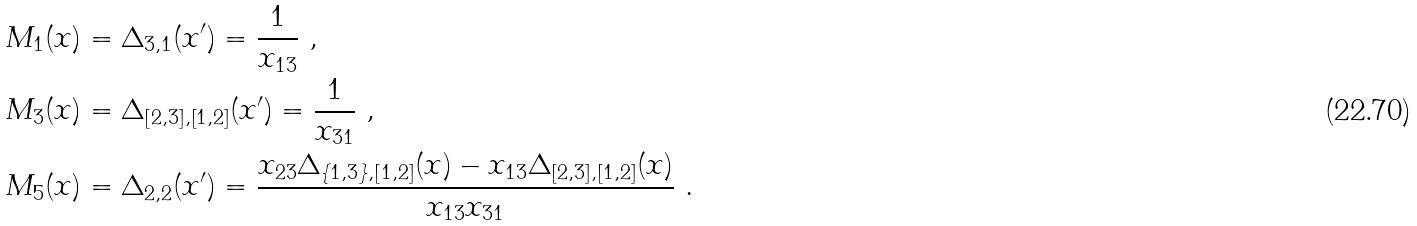<formula> <loc_0><loc_0><loc_500><loc_500>& M _ { 1 } ( x ) = \Delta _ { 3 , 1 } ( x ^ { \prime } ) = \frac { 1 } { x _ { 1 3 } } \ , \\ & M _ { 3 } ( x ) = \Delta _ { [ 2 , 3 ] , [ 1 , 2 ] } ( x ^ { \prime } ) = \frac { 1 } { x _ { 3 1 } } \ , \\ & M _ { 5 } ( x ) = \Delta _ { 2 , 2 } ( x ^ { \prime } ) = \frac { x _ { 2 3 } \Delta _ { \{ 1 , 3 \} , [ 1 , 2 ] } ( x ) - x _ { 1 3 } \Delta _ { [ 2 , 3 ] , [ 1 , 2 ] } ( x ) } { x _ { 1 3 } x _ { 3 1 } } \ .</formula> 